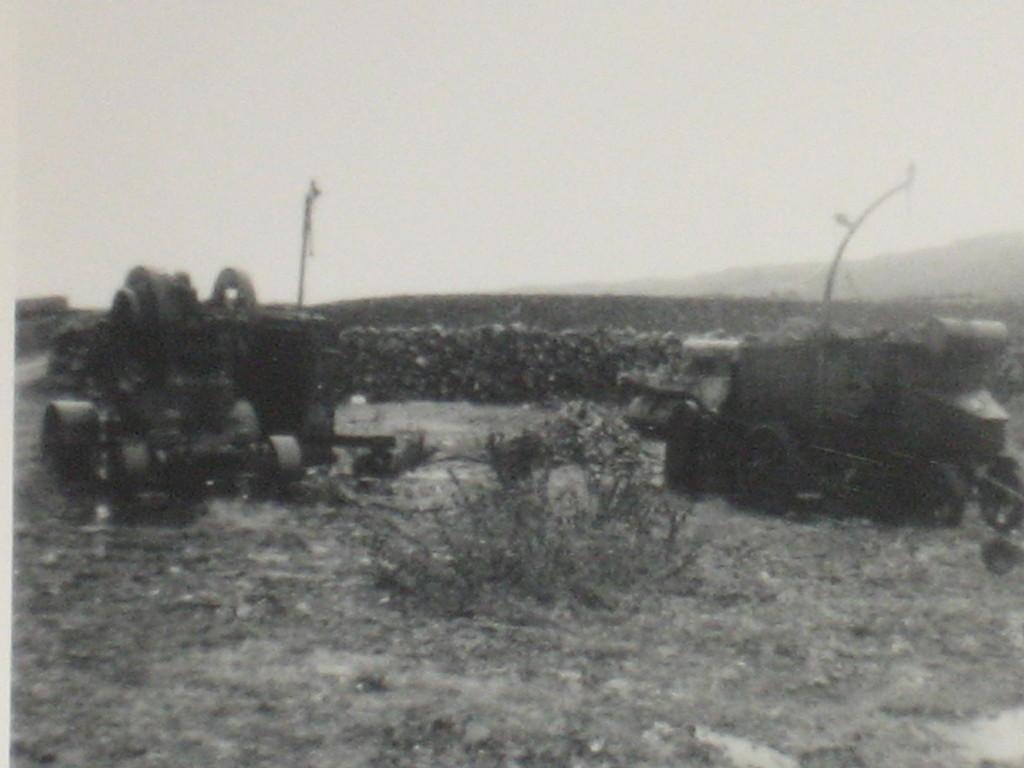Please provide a concise description of this image. It is a black and image. In this image, we can see vehicles, poles, wall and plants. Background we can see the sky. 